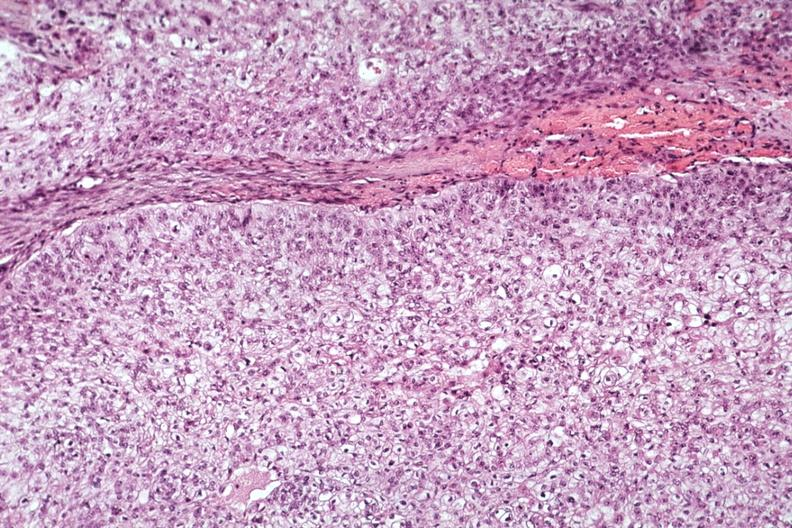where is this part in the figure?
Answer the question using a single word or phrase. Endocrine system 